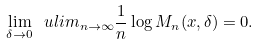<formula> <loc_0><loc_0><loc_500><loc_500>\lim _ { \delta \to 0 } \ u l i m _ { n \to \infty } \frac { 1 } { n } \log M _ { n } ( x , \delta ) = 0 .</formula> 